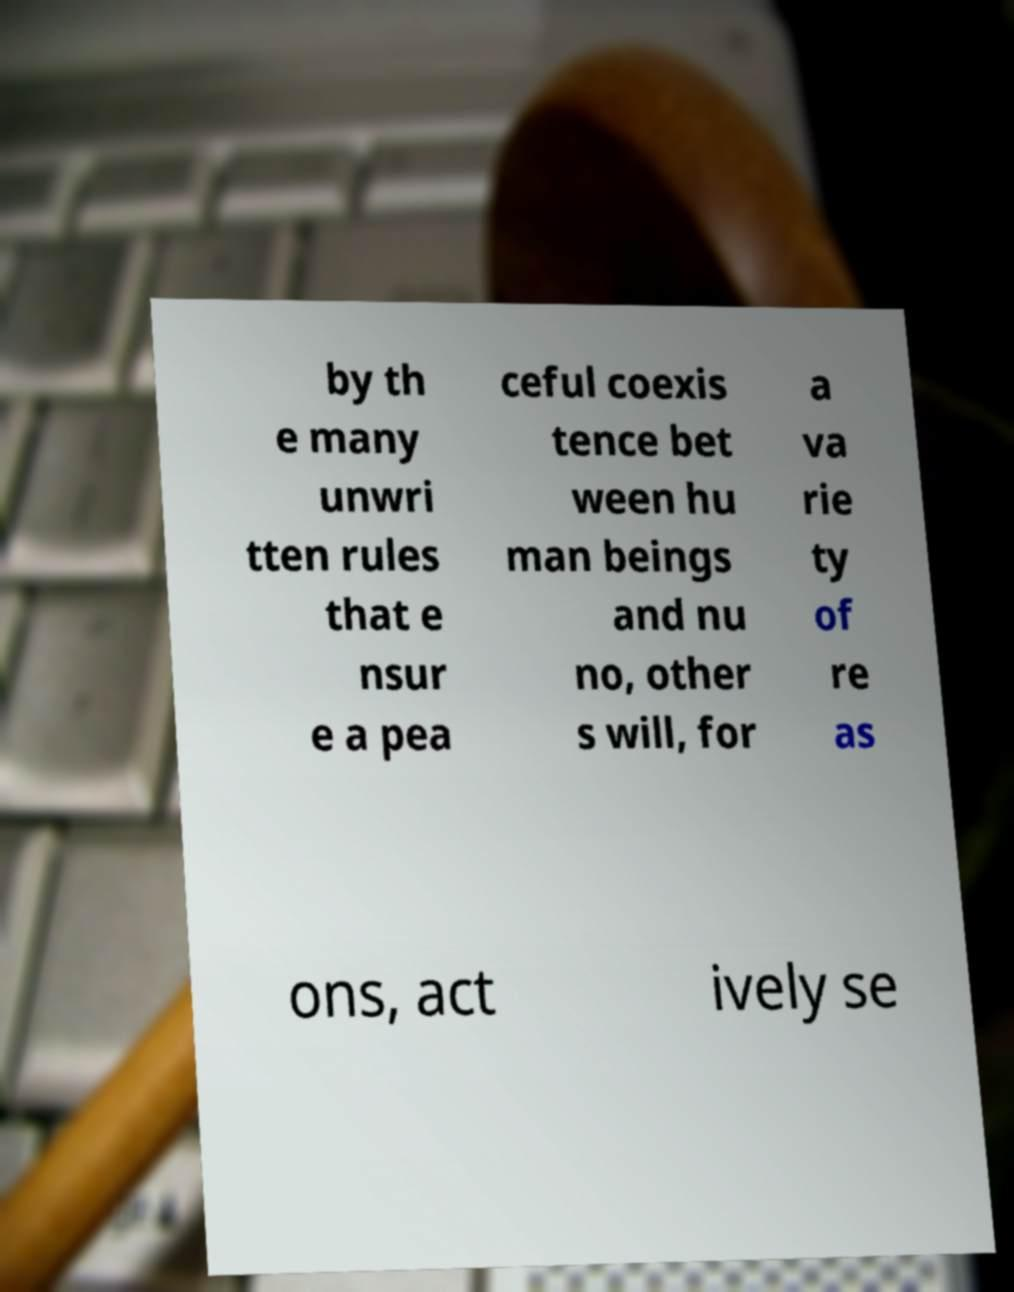Could you extract and type out the text from this image? by th e many unwri tten rules that e nsur e a pea ceful coexis tence bet ween hu man beings and nu no, other s will, for a va rie ty of re as ons, act ively se 